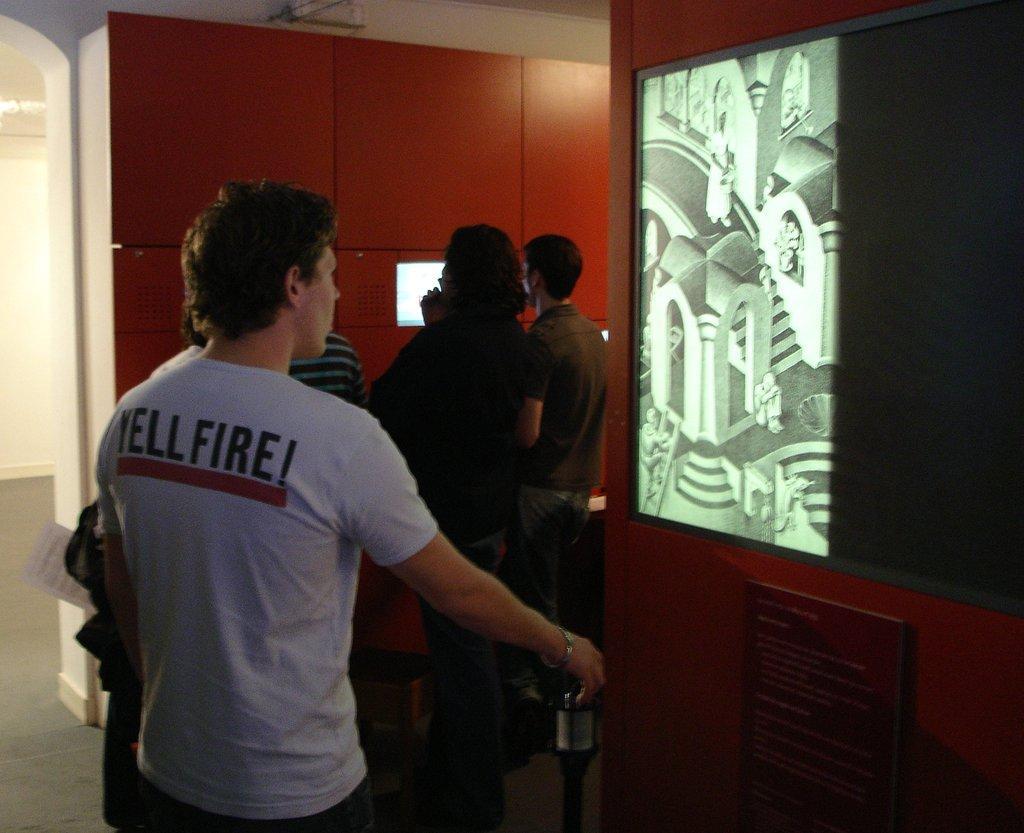Describe this image in one or two sentences. In this image we can see a man is standing. He is wearing white color t-shirt and seeing to one photograph, which is on the red color wall. Behind the man, three more persons are standing and watching to other photograph which is on the other wall. Right bottom of the image one frame is attached to the wall and one pole is there. 